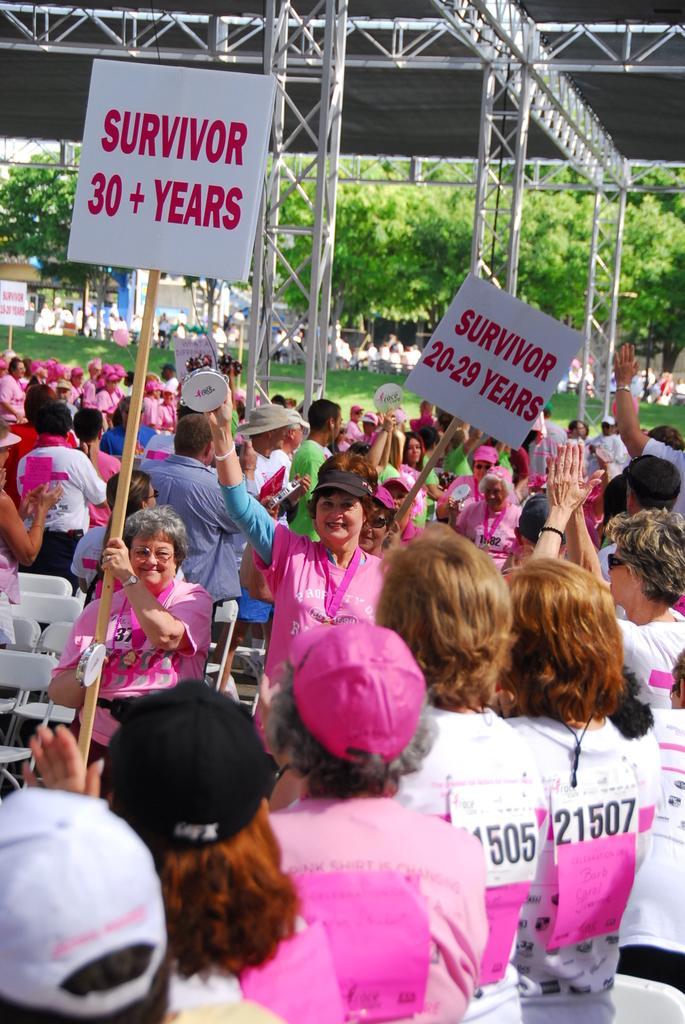Could you give a brief overview of what you see in this image? In this picture there are few people wearing white and pink color dress where two among them are holding a stick which has a board attached to it and there are few iron rods and trees in the background. 